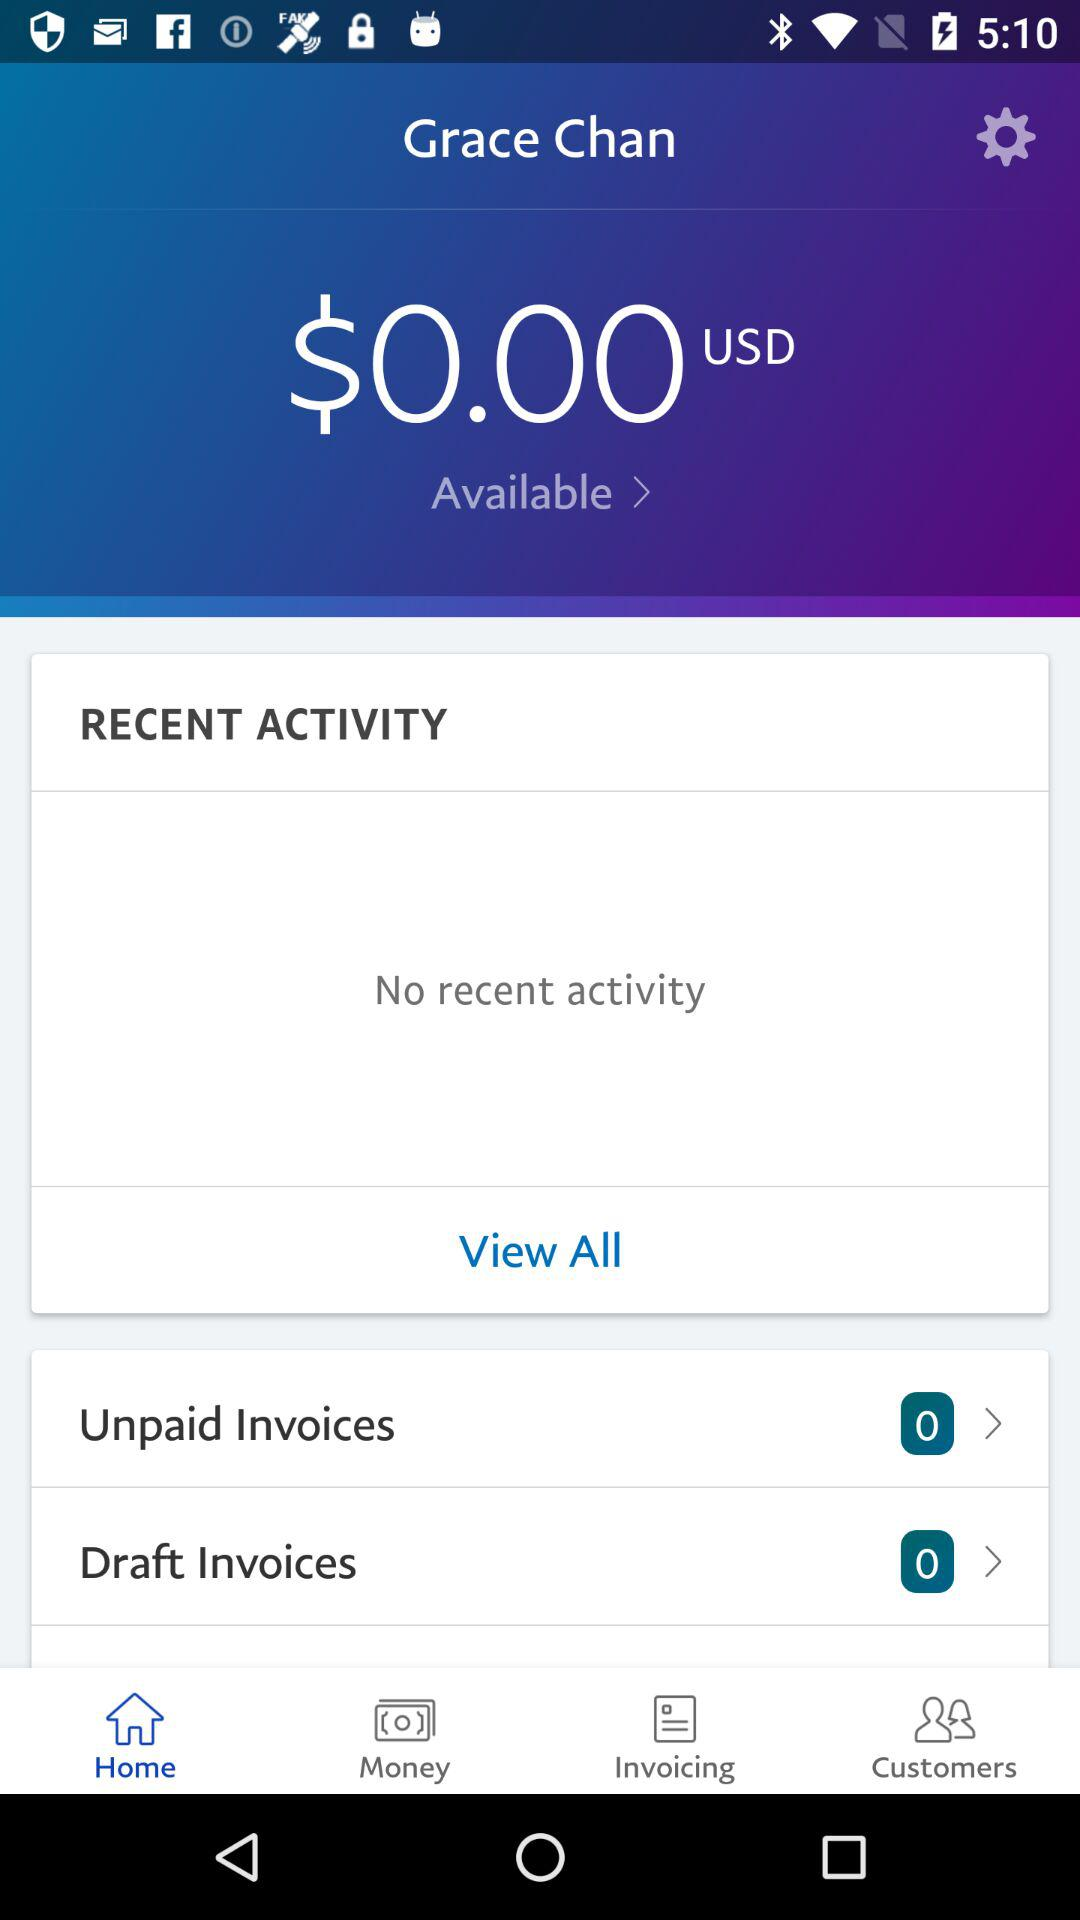Which tab am I using? You are using the "Home" tab. 